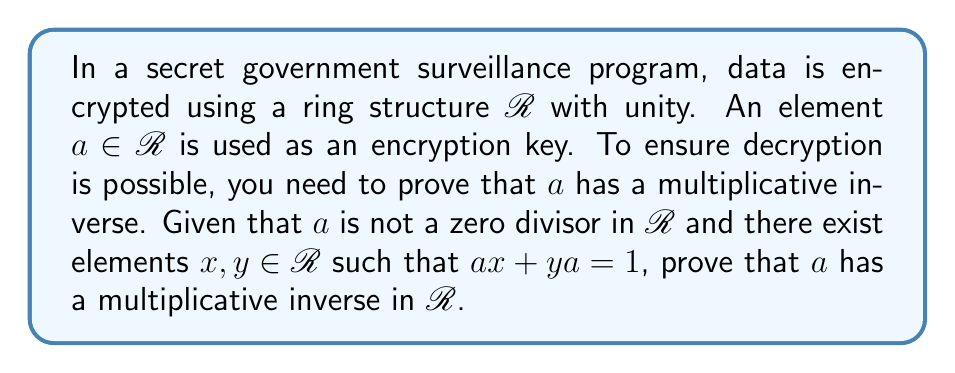Teach me how to tackle this problem. To prove the existence of a multiplicative inverse for $a$ in the ring $R$, we'll follow these steps:

1) We are given that $a$ is not a zero divisor and that there exist elements $x, y \in R$ such that $ax + ya = 1$.

2) Let's multiply both sides of the equation $ax + ya = 1$ by $a$:

   $a(ax + ya) = a \cdot 1 = a$

3) Distribute $a$ on the left side:

   $a^2x + aya = a$

4) Using the associative property of multiplication in rings, we can rewrite this as:

   $a(ax) + (ay)a = a$

5) Now, let's use the distributive property to factor out $a$:

   $a(ax + y) = a$

6) Let's define a new element $b = ax + y$. Then we have:

   $ab = a$

7) Subtracting $a$ from both sides:

   $ab - a = 0$

8) Factoring out $a$:

   $a(b - 1) = 0$

9) Since $a$ is not a zero divisor, this implies that $b - 1 = 0$, or $b = 1$.

10) Recall that $b = ax + y$. So we have:

    $ax + y = 1$

11) This is exactly the same form as our original equation $ax + ya = 1$. Comparing these, we can conclude that $y = ya$.

12) Therefore, $x$ is a right inverse of $a$ and $y$ is a left inverse of $a$.

13) In a ring with unity, if an element has both a left inverse and a right inverse, these inverses are equal and the element has a unique two-sided inverse.

Therefore, we have proven that $a$ has a multiplicative inverse in $R$, and this inverse is $x$ (or equivalently, $y$).
Answer: The element $a$ has a multiplicative inverse in $R$, and this inverse is $x$ (or $y$), where $x$ and $y$ are the elements satisfying $ax + ya = 1$. 